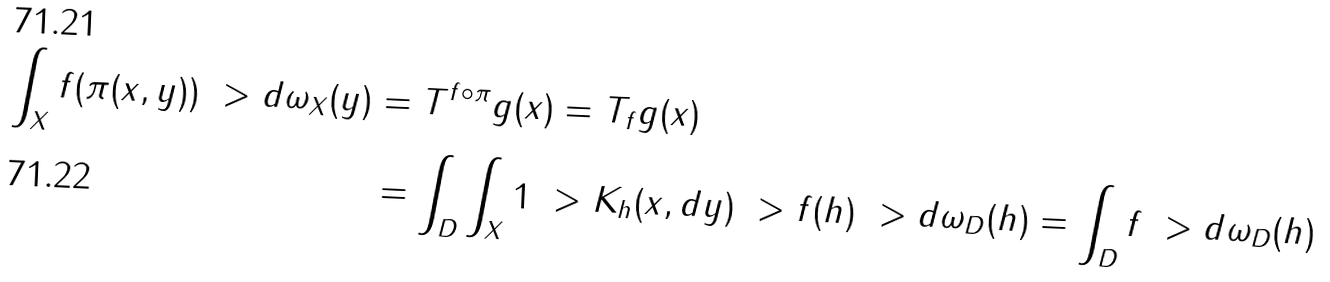<formula> <loc_0><loc_0><loc_500><loc_500>\int _ { X } f ( \pi ( x , y ) ) \ > d \omega _ { X } ( y ) & = T ^ { f \circ \pi } g ( x ) = T _ { f } g ( x ) \\ & = \int _ { D } \int _ { X } 1 \ > K _ { h } ( x , d y ) \ > f ( h ) \ > d \omega _ { D } ( h ) = \int _ { D } f \ > d \omega _ { D } ( h )</formula> 